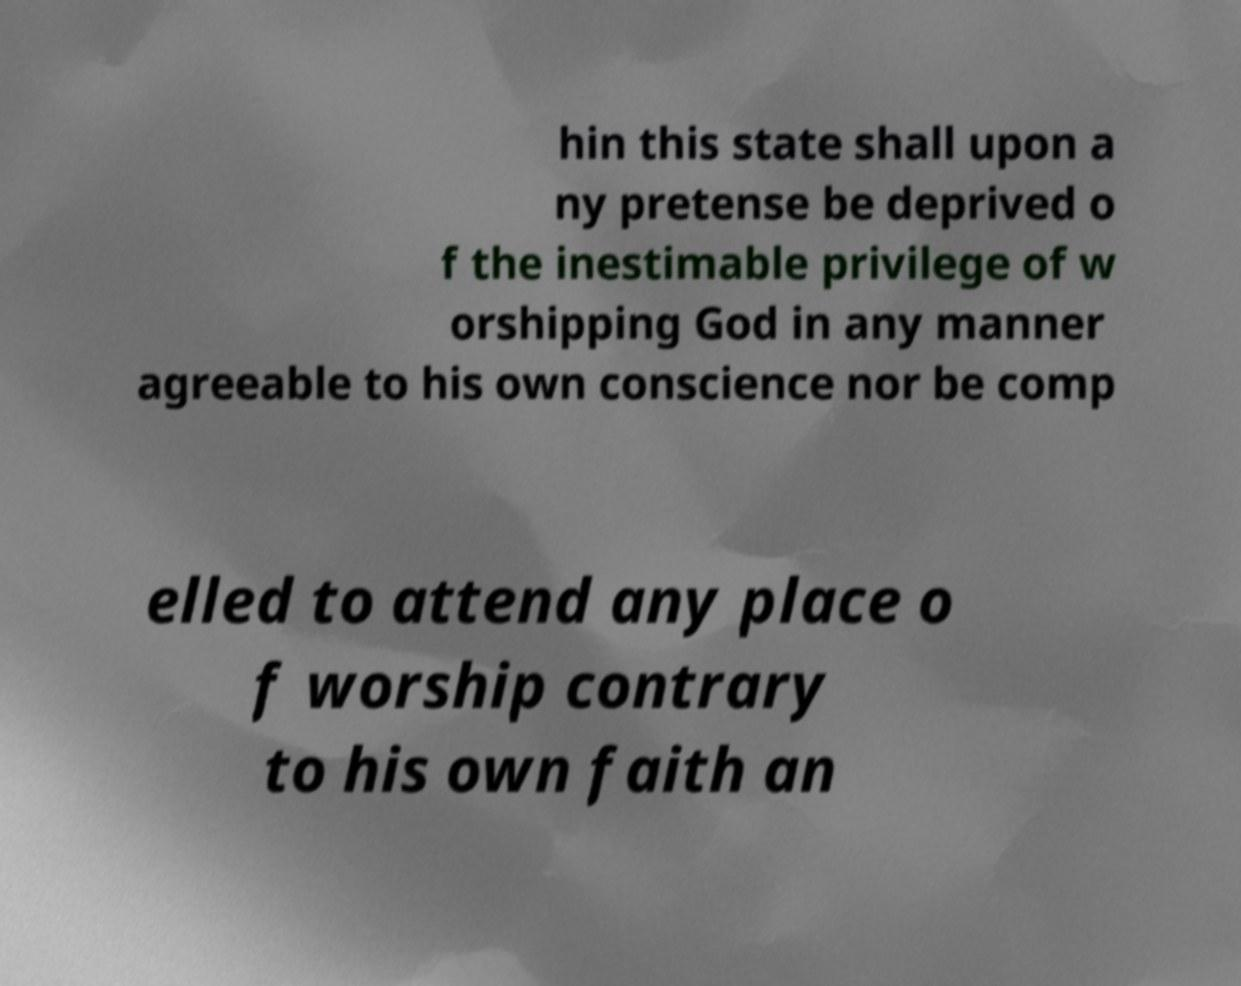I need the written content from this picture converted into text. Can you do that? hin this state shall upon a ny pretense be deprived o f the inestimable privilege of w orshipping God in any manner agreeable to his own conscience nor be comp elled to attend any place o f worship contrary to his own faith an 